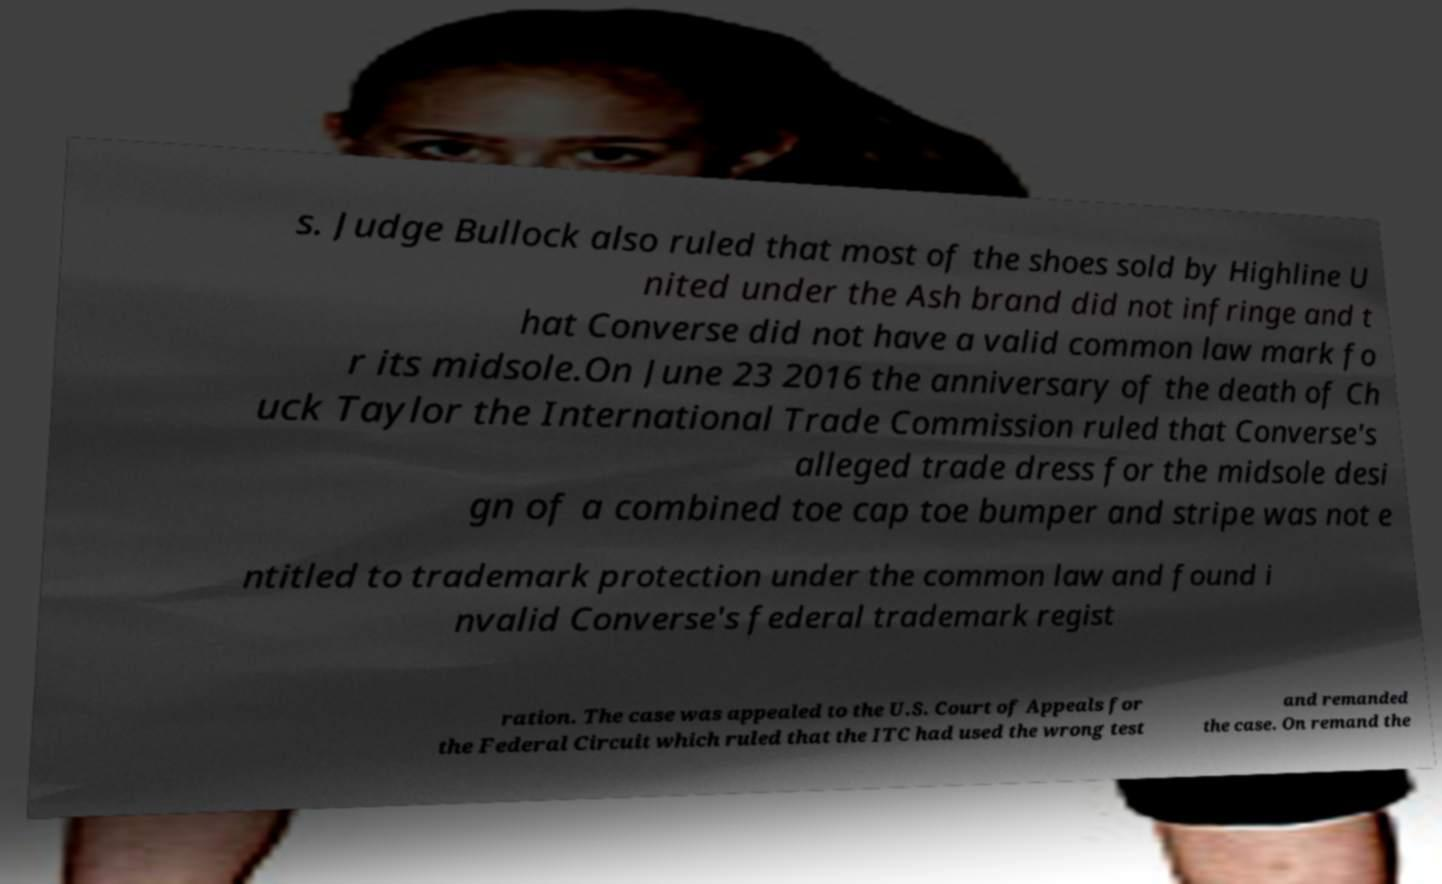Please read and relay the text visible in this image. What does it say? s. Judge Bullock also ruled that most of the shoes sold by Highline U nited under the Ash brand did not infringe and t hat Converse did not have a valid common law mark fo r its midsole.On June 23 2016 the anniversary of the death of Ch uck Taylor the International Trade Commission ruled that Converse's alleged trade dress for the midsole desi gn of a combined toe cap toe bumper and stripe was not e ntitled to trademark protection under the common law and found i nvalid Converse's federal trademark regist ration. The case was appealed to the U.S. Court of Appeals for the Federal Circuit which ruled that the ITC had used the wrong test and remanded the case. On remand the 